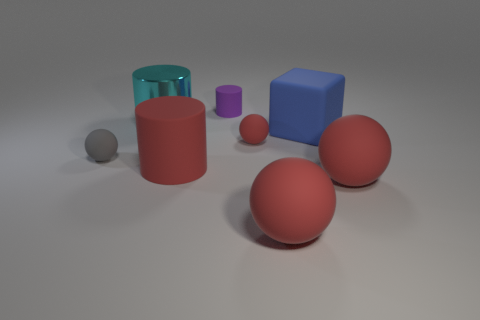How many red spheres must be subtracted to get 1 red spheres? 2 Subtract all purple cylinders. How many red balls are left? 3 Subtract all purple cylinders. How many cylinders are left? 2 Subtract all gray balls. How many balls are left? 3 Subtract 2 balls. How many balls are left? 2 Add 2 tiny things. How many objects exist? 10 Subtract all blocks. How many objects are left? 7 Subtract all brown cylinders. Subtract all yellow cubes. How many cylinders are left? 3 Add 4 large cylinders. How many large cylinders exist? 6 Subtract 0 blue cylinders. How many objects are left? 8 